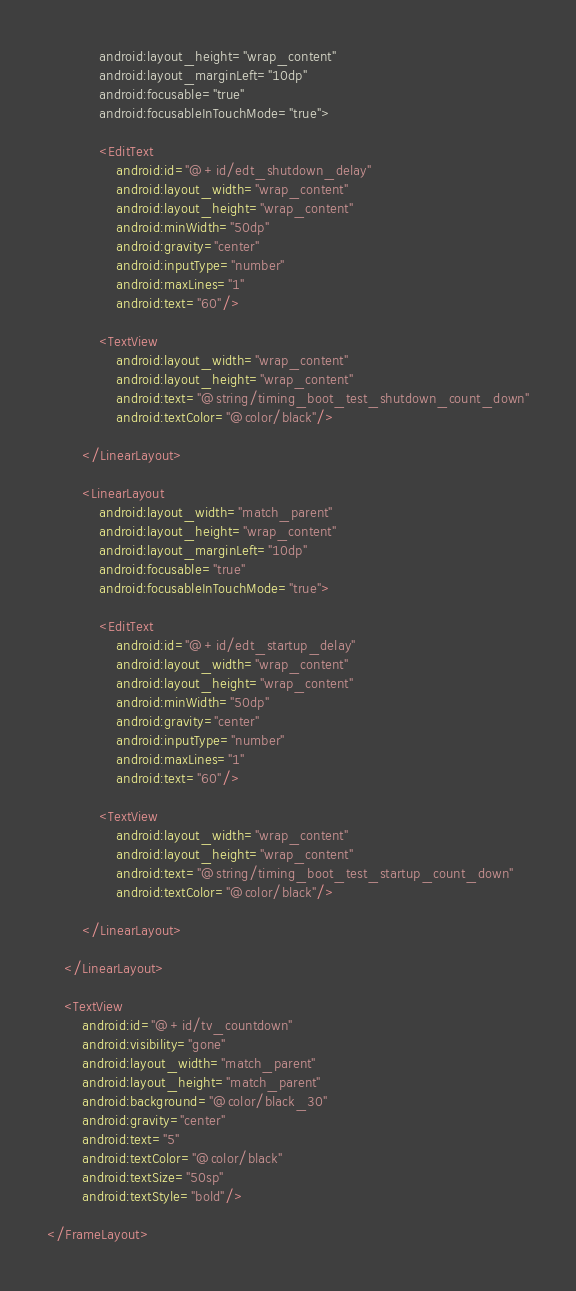<code> <loc_0><loc_0><loc_500><loc_500><_XML_>            android:layout_height="wrap_content"
            android:layout_marginLeft="10dp"
            android:focusable="true"
            android:focusableInTouchMode="true">

            <EditText
                android:id="@+id/edt_shutdown_delay"
                android:layout_width="wrap_content"
                android:layout_height="wrap_content"
                android:minWidth="50dp"
                android:gravity="center"
                android:inputType="number"
                android:maxLines="1"
                android:text="60"/>

            <TextView
                android:layout_width="wrap_content"
                android:layout_height="wrap_content"
                android:text="@string/timing_boot_test_shutdown_count_down"
                android:textColor="@color/black"/>

        </LinearLayout>

        <LinearLayout
            android:layout_width="match_parent"
            android:layout_height="wrap_content"
            android:layout_marginLeft="10dp"
            android:focusable="true"
            android:focusableInTouchMode="true">

            <EditText
                android:id="@+id/edt_startup_delay"
                android:layout_width="wrap_content"
                android:layout_height="wrap_content"
                android:minWidth="50dp"
                android:gravity="center"
                android:inputType="number"
                android:maxLines="1"
                android:text="60"/>

            <TextView
                android:layout_width="wrap_content"
                android:layout_height="wrap_content"
                android:text="@string/timing_boot_test_startup_count_down"
                android:textColor="@color/black"/>

        </LinearLayout>

    </LinearLayout>

    <TextView
        android:id="@+id/tv_countdown"
        android:visibility="gone"
        android:layout_width="match_parent"
        android:layout_height="match_parent"
        android:background="@color/black_30"
        android:gravity="center"
        android:text="5"
        android:textColor="@color/black"
        android:textSize="50sp"
        android:textStyle="bold"/>

</FrameLayout>
</code> 